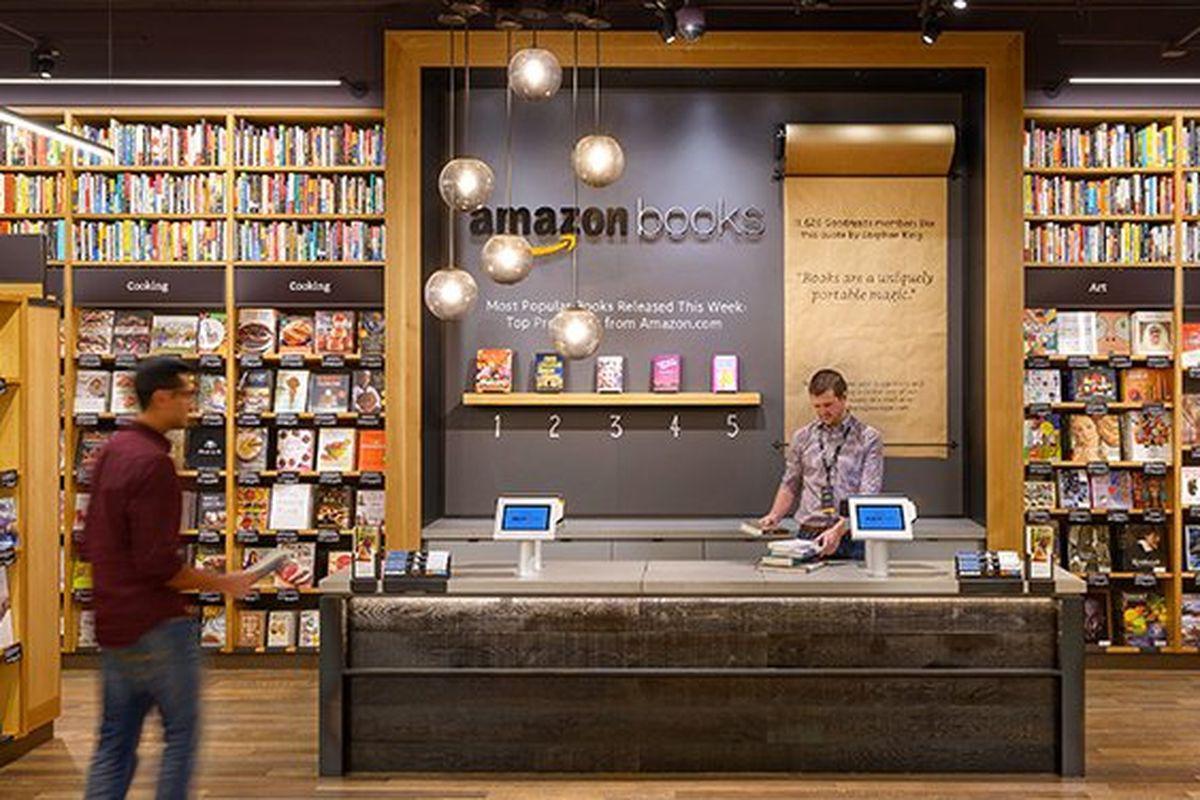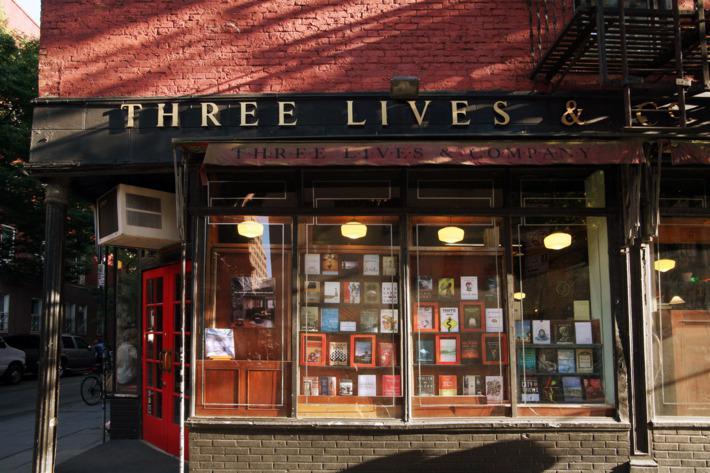The first image is the image on the left, the second image is the image on the right. Analyze the images presented: Is the assertion "There is one image taken of the inside of the bookstore" valid? Answer yes or no. Yes. 